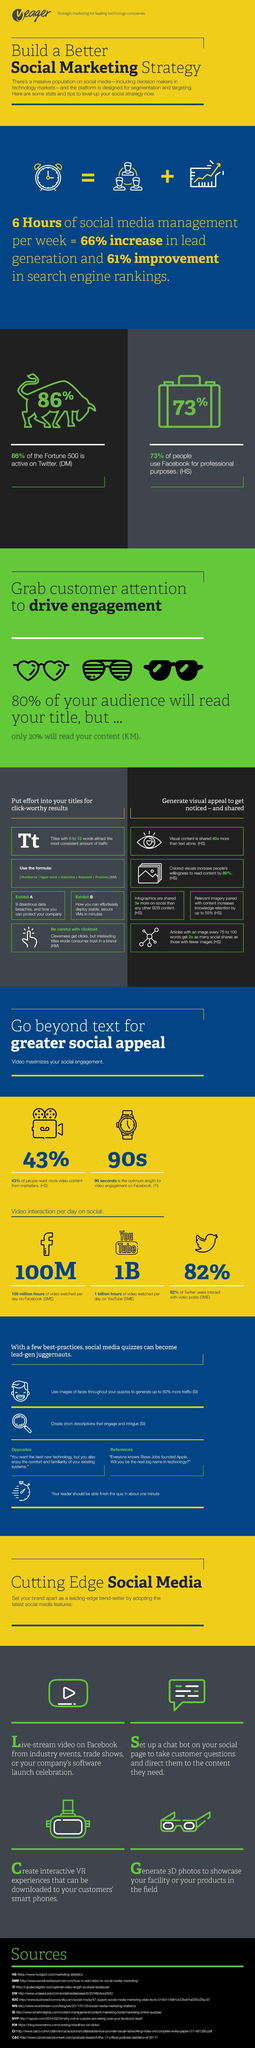What percentage of Fortune 500 is not active on Twitter?
Answer the question with a short phrase. 14 Which social media has the second highest video interaction per day- Facebook, YouTube, Twitter, Instagram ? YouTube What percentage of people do not want more video content from marketers? 57 What percentage of people does not use Facebook? 27 How much time YouTube videos are being watched in a day? 1 billion hours 